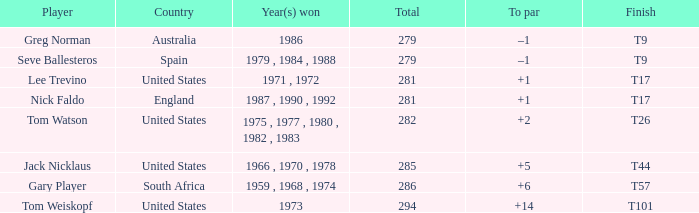Which sportsman is from australia? Greg Norman. 